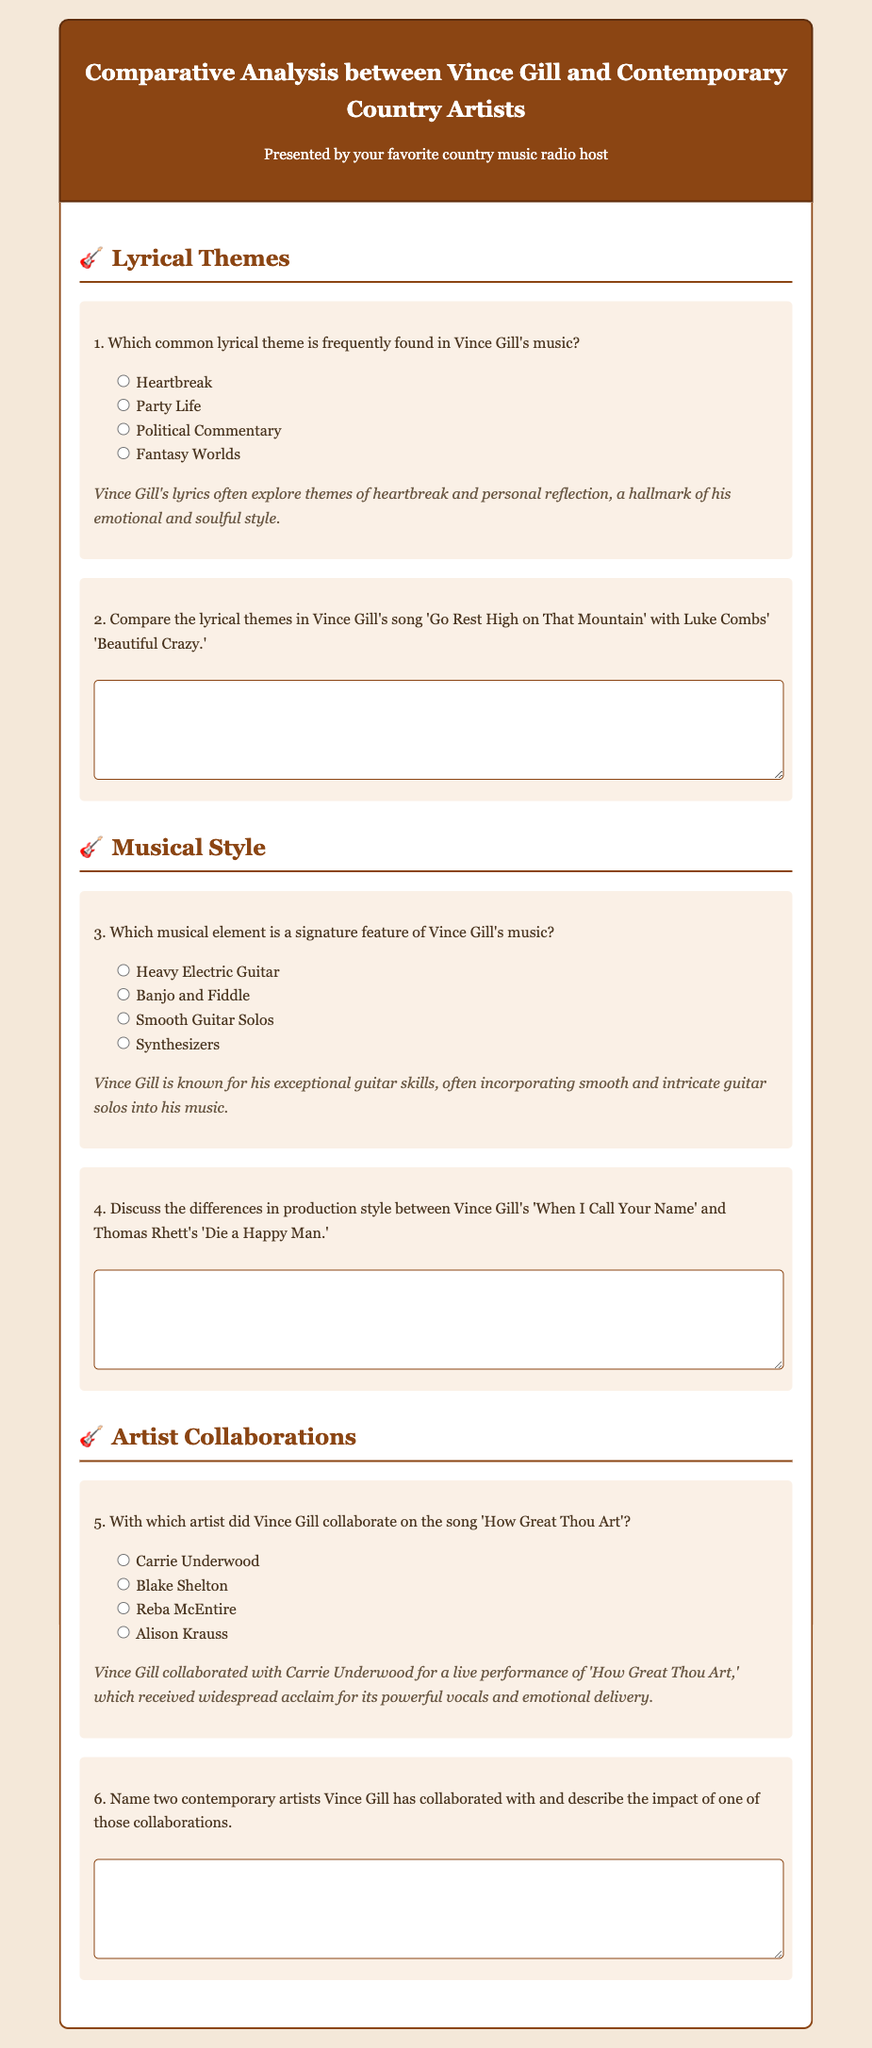What common lyrical theme is found in Vince Gill's music? The document states that Vince Gill's lyrics often explore themes of heartbreak and personal reflection.
Answer: Heartbreak Which musical element characterizes Vince Gill's music? The document mentions that Vince Gill is known for his exceptional guitar skills, focusing on smooth and intricate guitar solos.
Answer: Smooth Guitar Solos Who collaborated with Vince Gill on 'How Great Thou Art'? The document highlights that Vince Gill collaborated with Carrie Underwood for a live performance of 'How Great Thou Art.'
Answer: Carrie Underwood What song by Vince Gill is compared with Luke Combs' song? The document states the comparison is made between 'Go Rest High on That Mountain' and 'Beautiful Crazy.'
Answer: 'Go Rest High on That Mountain' Name one contemporary artist mentioned that Vince Gill has collaborated with. The document implies that multiple contemporary artists are mentioned, but does not specify; however, the question can be answered with one they likely know of.
Answer: Carrie Underwood What is the main topic of the exam? The document's title and content clearly focus on the comparative analysis between Vince Gill and contemporary country artists covering various aspects.
Answer: Comparative Analysis between Vince Gill and Contemporary Country Artists 